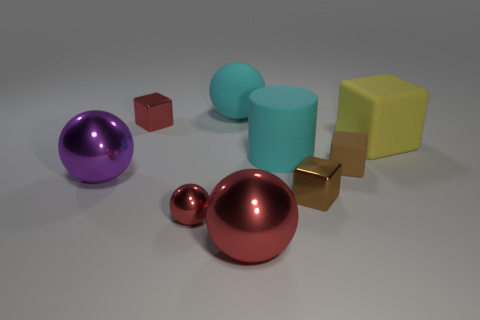Is there another large matte block that has the same color as the large matte block?
Keep it short and to the point. No. Are the large red sphere that is in front of the brown matte cube and the sphere behind the tiny red metal block made of the same material?
Provide a succinct answer. No. What is the size of the cyan rubber thing in front of the yellow cube?
Ensure brevity in your answer.  Large. The cylinder has what size?
Keep it short and to the point. Large. There is a brown cube that is behind the shiny cube that is in front of the tiny red metallic thing that is behind the large yellow block; what size is it?
Your answer should be very brief. Small. Are there any yellow cubes that have the same material as the large cyan cylinder?
Provide a short and direct response. Yes. What is the shape of the yellow rubber thing?
Provide a succinct answer. Cube. There is another small cube that is made of the same material as the red cube; what color is it?
Make the answer very short. Brown. What number of yellow things are either metallic spheres or metal cylinders?
Give a very brief answer. 0. Are there more yellow objects than tiny red rubber things?
Your response must be concise. Yes. 